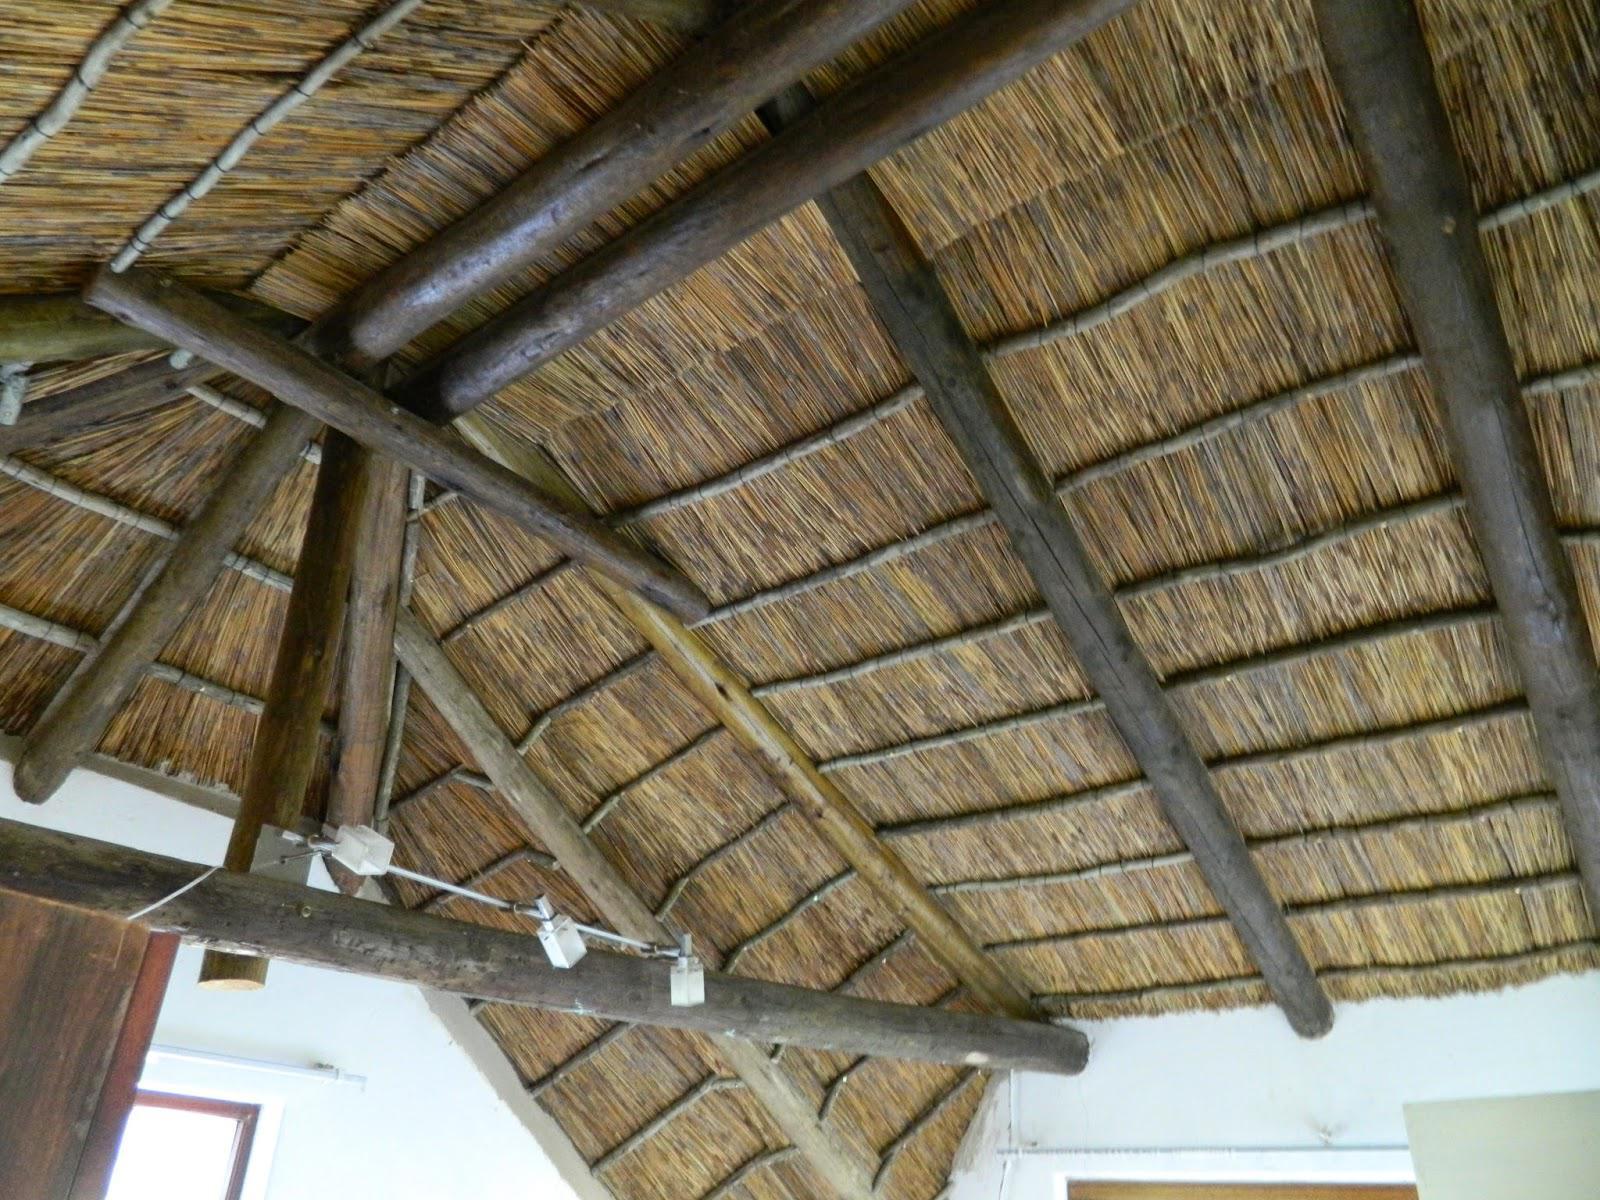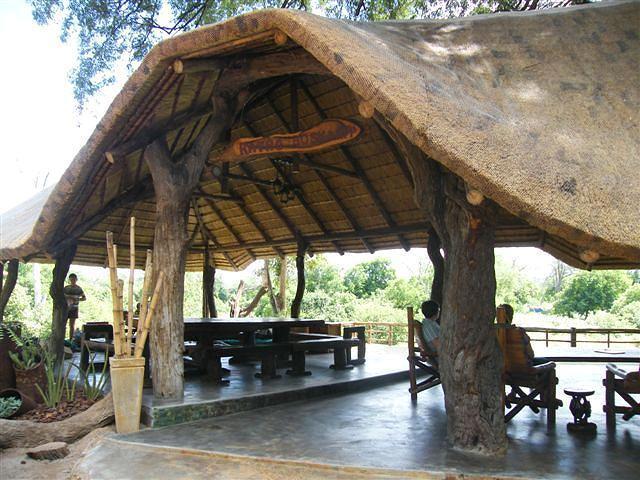The first image is the image on the left, the second image is the image on the right. For the images shown, is this caption "The vertical posts are real tree trunks." true? Answer yes or no. Yes. The first image is the image on the left, the second image is the image on the right. Examine the images to the left and right. Is the description "The right image shows a roof made of plant material draped over leafless tree supports with forked limbs." accurate? Answer yes or no. Yes. 